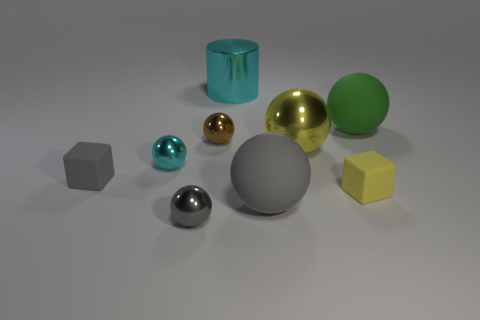There is a metal object that is both on the right side of the small brown object and in front of the green matte thing; what shape is it? sphere 